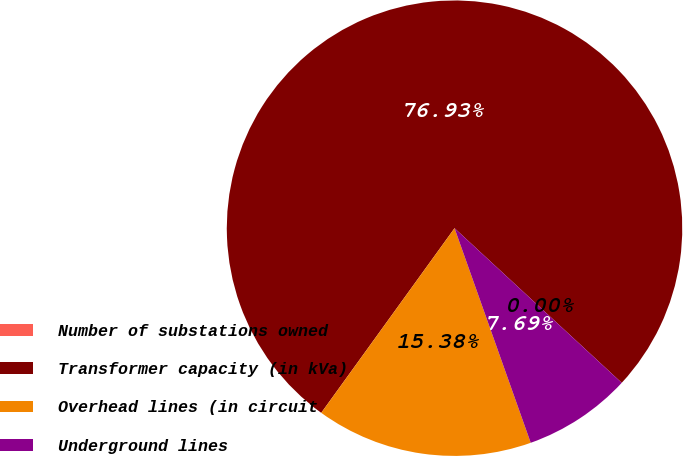Convert chart to OTSL. <chart><loc_0><loc_0><loc_500><loc_500><pie_chart><fcel>Number of substations owned<fcel>Transformer capacity (in kVa)<fcel>Overhead lines (in circuit<fcel>Underground lines<nl><fcel>0.0%<fcel>76.92%<fcel>15.38%<fcel>7.69%<nl></chart> 